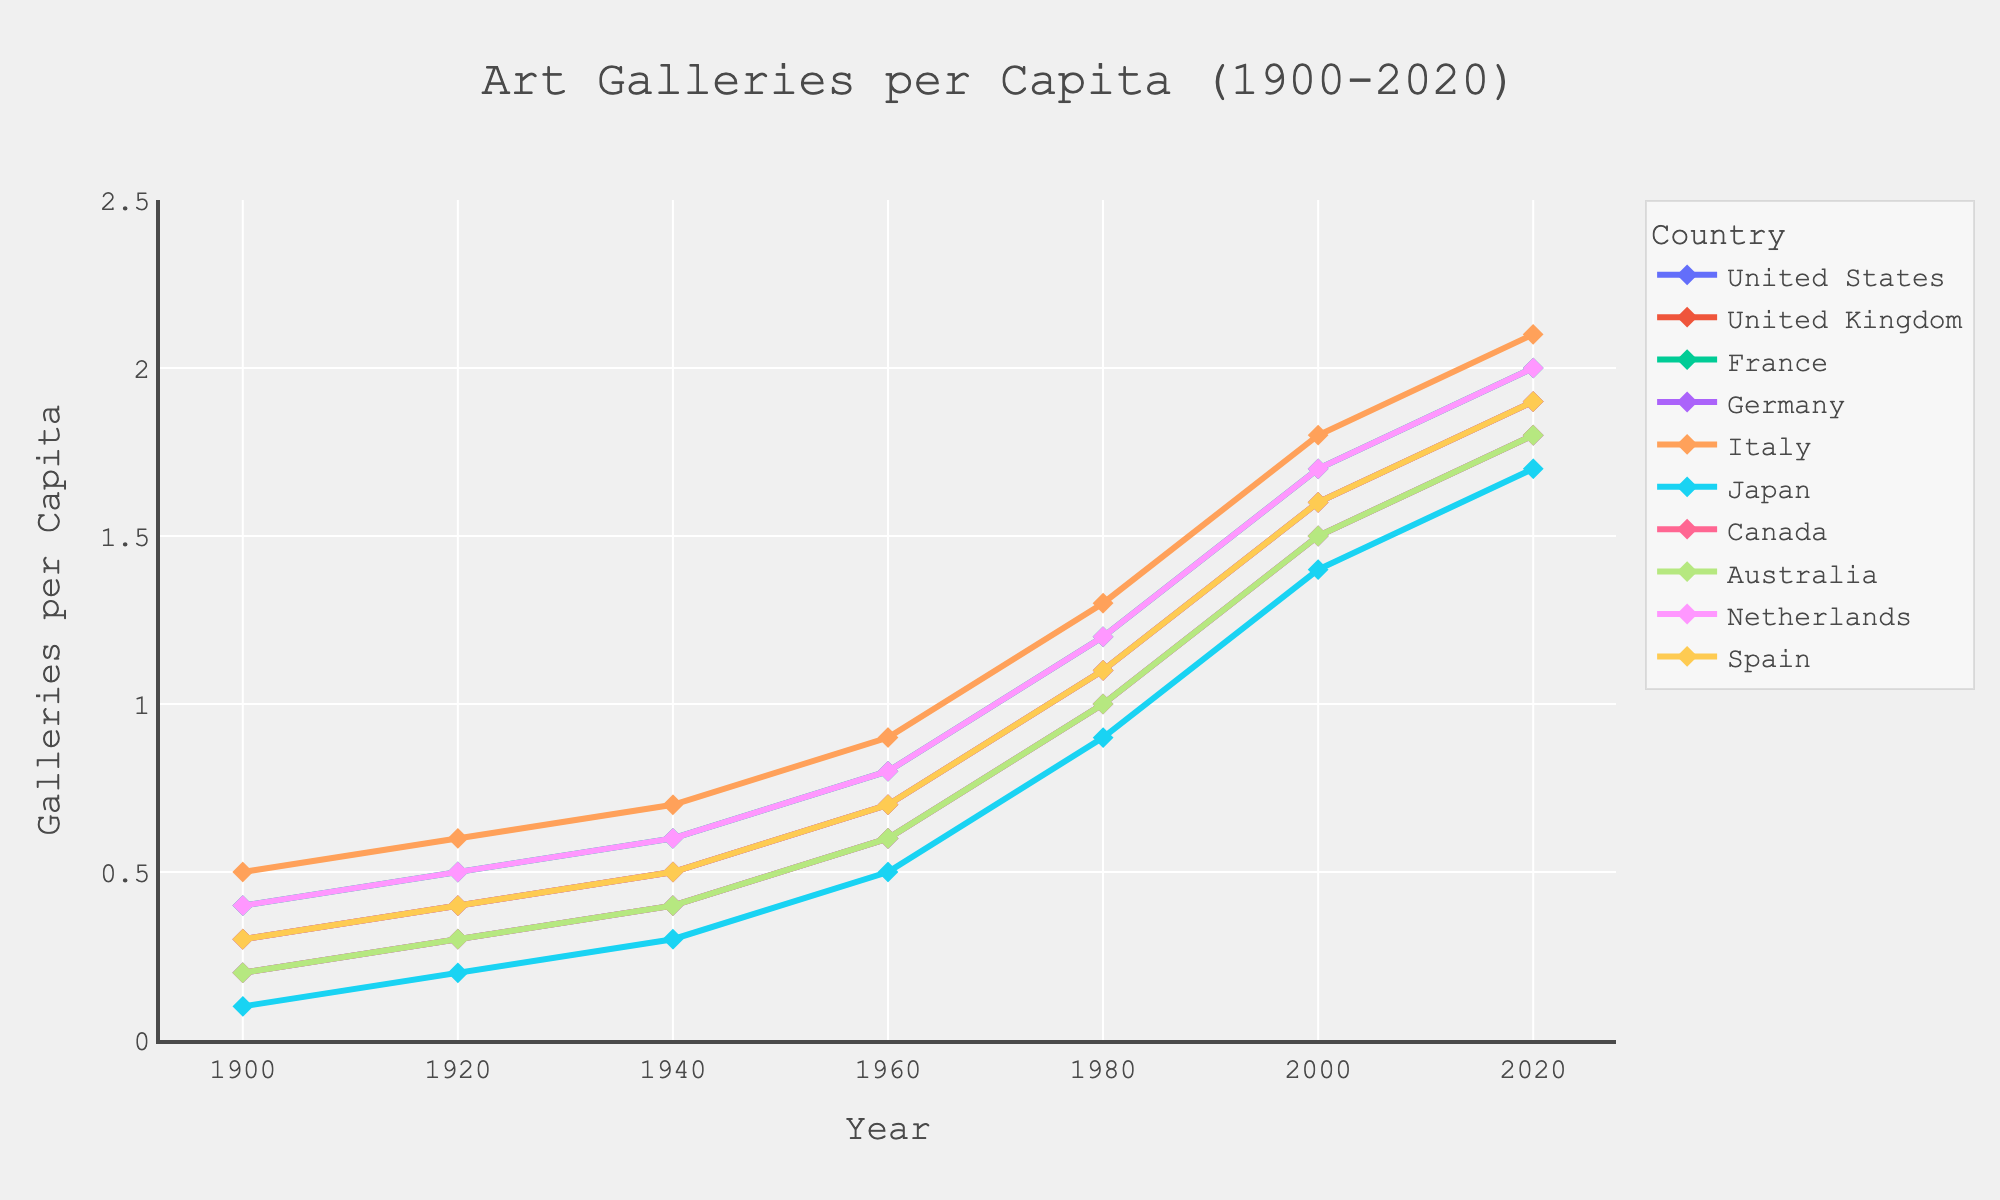Which country has the highest number of art galleries per capita in 2020? In 2020, Italy leads with 2.1 art galleries per capita, followed by France and the Netherlands tied at 2.0 per capita.
Answer: Italy What is the trend for Japan from 1900 to 2020? The number of art galleries per capita in Japan gradually increased from 0.1 in 1900 to 1.7 by 2020, showing steady growth.
Answer: Increasing Which country experienced the steepest increase between 1960 and 1980? By examining the slopes between 1960 and 1980, the United Kingdom and Germany both show a noticeable jump from 0.7 to 1.1, indicating a significant rise.
Answer: United Kingdom and Germany How many countries had 0.5 or fewer galleries per capita in 1940? In 1940, the United States, the United Kingdom, Germany, Japan, Canada, and Australia all had 0.5 or fewer art galleries per capita. A total of six countries.
Answer: 6 Compare the growth rates of the United States and the United Kingdom from 1920 to 2000. Which grew faster? The United States grew from 0.3 to 1.5 (a change of 1.2) and the United Kingdom grew from 0.4 to 1.6 (a change of 1.2) during the same period. Both countries have the same growth rate in this span.
Answer: Both grew at the same rate Which year saw the biggest leap in galleries per capita in France? Between 1940 and 1960, France's per capita number of art galleries rose from 0.6 to 0.8, a 0.2 increase. Comparing other intervals, this is the highest single leap observed.
Answer: 1940 to 1960 Did any country have a decline in the number of galleries per capita at any point? All countries show a continual increase in their galleries per capita from 1900 to 2020. There was no period of decline for any country in the dataset.
Answer: No By how much did Italy's number of galleries per capita increase from 1900 to 2020? Italy's number of art galleries per capita rose from 0.5 in 1900 to 2.1 in 2020, marking an increase of 2.1 - 0.5 = 1.6.
Answer: 1.6 What is the total number of galleries per capita for all countries combined in 1980? The total number of galleries per capita for all countries in 1980 can be calculated by summing up the values: United States (1.0) + United Kingdom (1.1) + France (1.2) + Germany (1.1) + Italy (1.3) + Japan (0.9) + Canada (1.0) + Australia (1.0) + Netherlands (1.2) + Spain (1.1) = 10.9
Answer: 10.9 Which three countries show consistent growth without stagnation from 1900 to 2020? Italy, France, and the Netherlands all demonstrate consistent growth without any periods of stagnation or decrease across each evaluated year.
Answer: Italy, France, Netherlands 